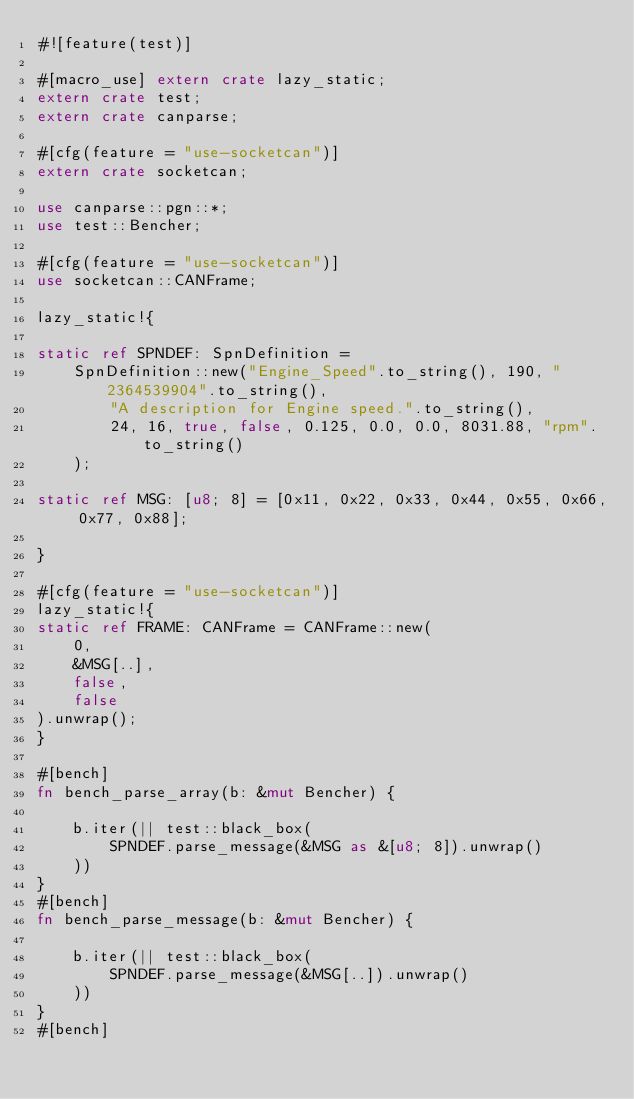Convert code to text. <code><loc_0><loc_0><loc_500><loc_500><_Rust_>#![feature(test)]

#[macro_use] extern crate lazy_static;
extern crate test;
extern crate canparse;

#[cfg(feature = "use-socketcan")]
extern crate socketcan;

use canparse::pgn::*;
use test::Bencher;

#[cfg(feature = "use-socketcan")]
use socketcan::CANFrame;

lazy_static!{

static ref SPNDEF: SpnDefinition =
    SpnDefinition::new("Engine_Speed".to_string(), 190, "2364539904".to_string(),
        "A description for Engine speed.".to_string(),
        24, 16, true, false, 0.125, 0.0, 0.0, 8031.88, "rpm".to_string()
    );

static ref MSG: [u8; 8] = [0x11, 0x22, 0x33, 0x44, 0x55, 0x66, 0x77, 0x88];

}

#[cfg(feature = "use-socketcan")]
lazy_static!{
static ref FRAME: CANFrame = CANFrame::new(
    0,
    &MSG[..],
    false,
    false
).unwrap();
}

#[bench]
fn bench_parse_array(b: &mut Bencher) {

    b.iter(|| test::black_box(
        SPNDEF.parse_message(&MSG as &[u8; 8]).unwrap()
    ))
}
#[bench]
fn bench_parse_message(b: &mut Bencher) {

    b.iter(|| test::black_box(
        SPNDEF.parse_message(&MSG[..]).unwrap()
    ))
}
#[bench]</code> 